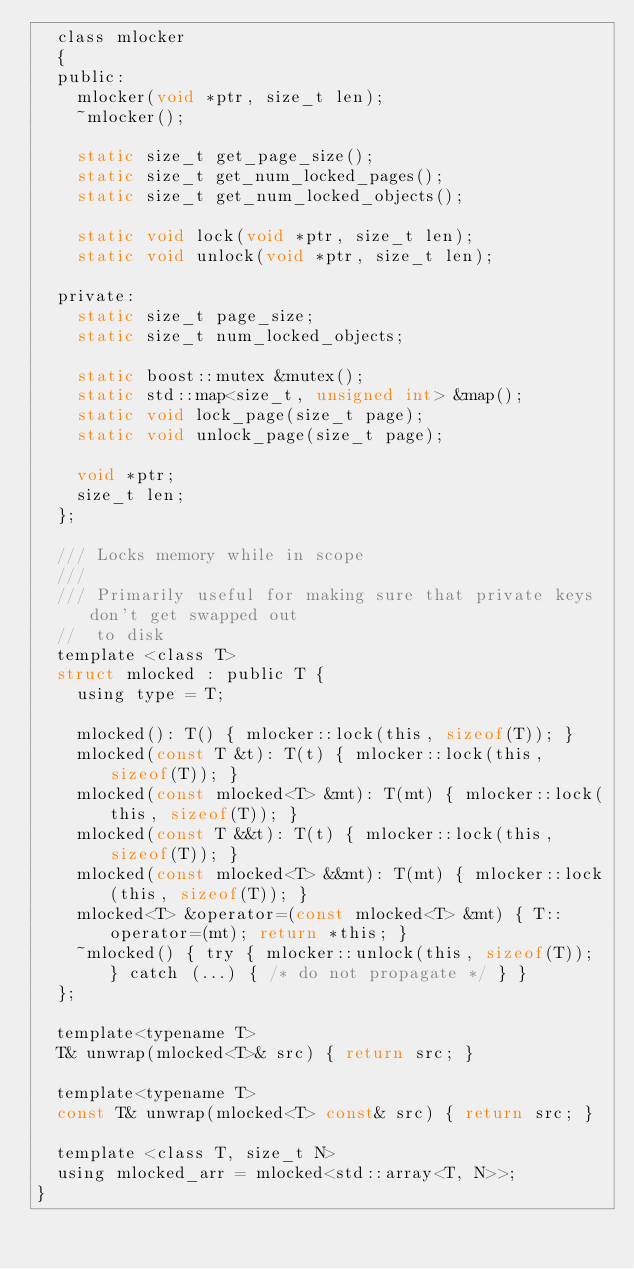<code> <loc_0><loc_0><loc_500><loc_500><_C_>  class mlocker
  {
  public:
    mlocker(void *ptr, size_t len);
    ~mlocker();

    static size_t get_page_size();
    static size_t get_num_locked_pages();
    static size_t get_num_locked_objects();

    static void lock(void *ptr, size_t len);
    static void unlock(void *ptr, size_t len);

  private:
    static size_t page_size;
    static size_t num_locked_objects;

    static boost::mutex &mutex();
    static std::map<size_t, unsigned int> &map();
    static void lock_page(size_t page);
    static void unlock_page(size_t page);

    void *ptr;
    size_t len;
  };

  /// Locks memory while in scope
  ///
  /// Primarily useful for making sure that private keys don't get swapped out
  //  to disk
  template <class T>
  struct mlocked : public T {
    using type = T;

    mlocked(): T() { mlocker::lock(this, sizeof(T)); }
    mlocked(const T &t): T(t) { mlocker::lock(this, sizeof(T)); }
    mlocked(const mlocked<T> &mt): T(mt) { mlocker::lock(this, sizeof(T)); }
    mlocked(const T &&t): T(t) { mlocker::lock(this, sizeof(T)); }
    mlocked(const mlocked<T> &&mt): T(mt) { mlocker::lock(this, sizeof(T)); }
    mlocked<T> &operator=(const mlocked<T> &mt) { T::operator=(mt); return *this; }
    ~mlocked() { try { mlocker::unlock(this, sizeof(T)); } catch (...) { /* do not propagate */ } }
  };

  template<typename T>
  T& unwrap(mlocked<T>& src) { return src; }

  template<typename T>
  const T& unwrap(mlocked<T> const& src) { return src; }

  template <class T, size_t N>
  using mlocked_arr = mlocked<std::array<T, N>>;
}
</code> 